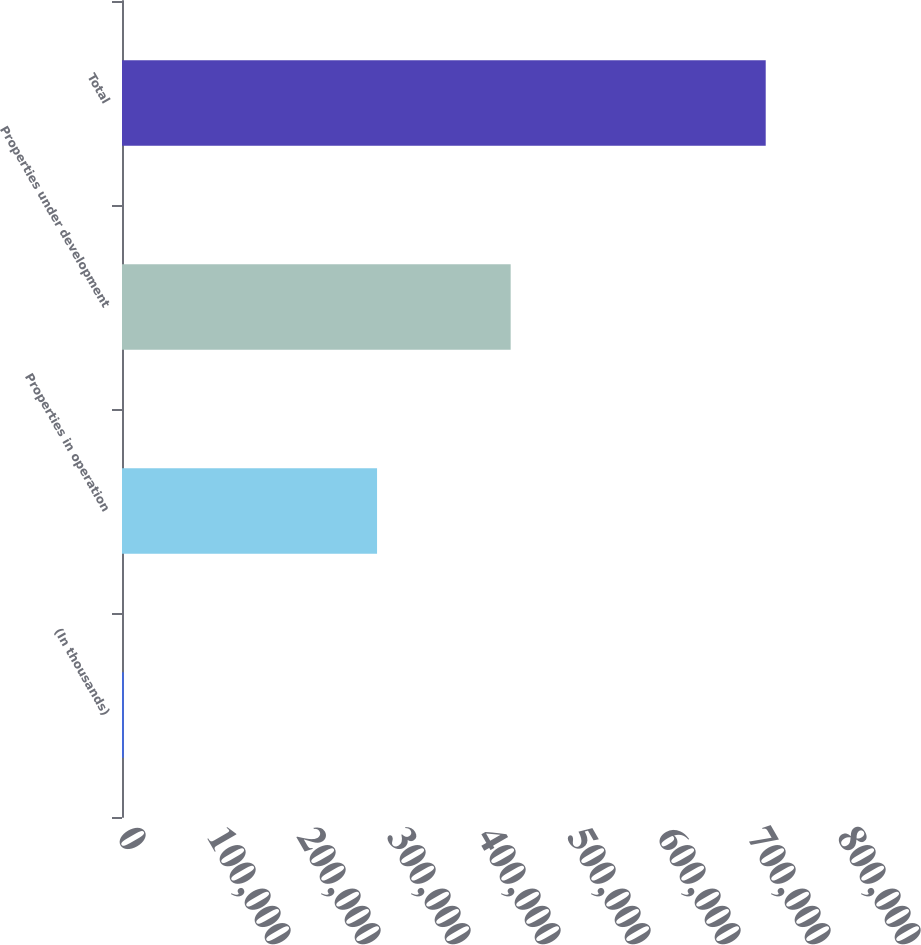Convert chart. <chart><loc_0><loc_0><loc_500><loc_500><bar_chart><fcel>(In thousands)<fcel>Properties in operation<fcel>Properties under development<fcel>Total<nl><fcel>2013<fcel>283393<fcel>431849<fcel>715242<nl></chart> 